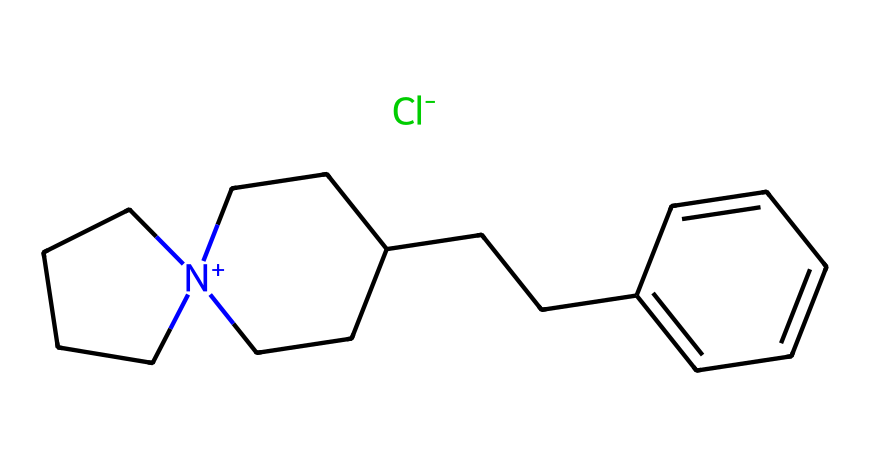What is the total number of carbon atoms in this ionic liquid? By analyzing the SMILES representation, we can count the carbon atoms. Each "(CC" or "C" denotes a carbon atom. There are 12 carbon atoms total in this structure.
Answer: 12 How many chlorine atoms are present in the chemical? Looking at the SMILES representation, we note the presence of "[Cl-]", which indicates there is one chlorine atom in the ionic liquid.
Answer: 1 What type of ion is represented at the end of this structure? The structure ends with "[Cl-]", indicating it is a chloride ion, which is a common anion in ionic liquids.
Answer: chloride Which part of this ionic liquid may contribute to its corrosion-resistant property when used in paint? The presence of the large organic cation (the bulky side chains) in the structure provides increased steric hindrance and stability, which contributes to corrosion resistance.
Answer: large organic cation How many nitrogen atoms are in the structure? The SMILES shows a nitrogen atom indicated by "[N+]". There is one nitrogen atom present in the ionic liquid structure.
Answer: 1 What charge does the nitrogen atom carry in this ionic liquid? In the SMILES, the nitrogen atom is shown with “[N+]”, which indicates that it has a positive charge.
Answer: positive charge 